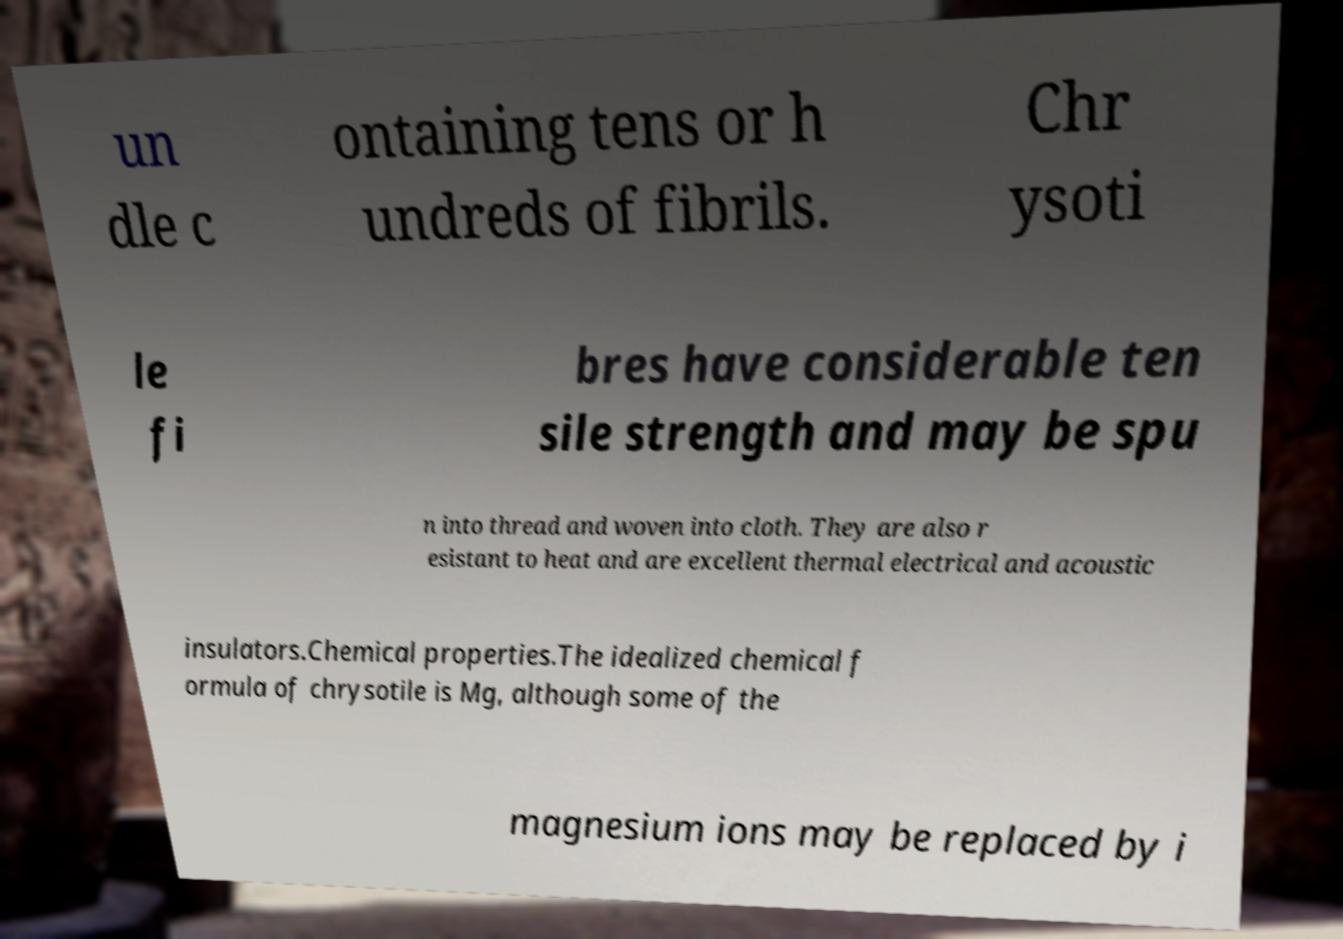Please identify and transcribe the text found in this image. un dle c ontaining tens or h undreds of fibrils. Chr ysoti le fi bres have considerable ten sile strength and may be spu n into thread and woven into cloth. They are also r esistant to heat and are excellent thermal electrical and acoustic insulators.Chemical properties.The idealized chemical f ormula of chrysotile is Mg, although some of the magnesium ions may be replaced by i 